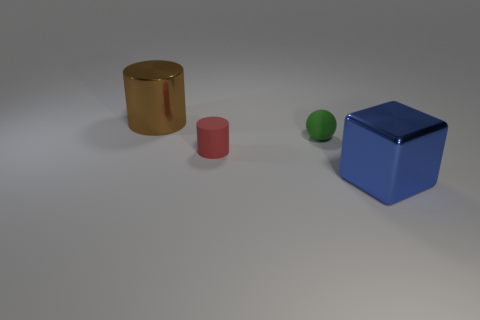The green rubber object that is the same size as the red matte thing is what shape? The green rubber object, which appears to be identical in size to the red matte cylinder, is a sphere. 